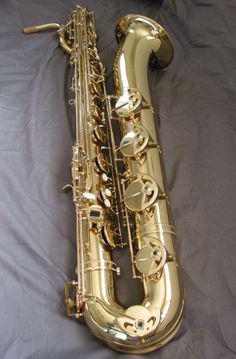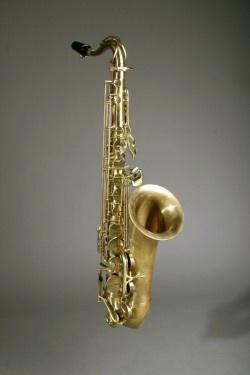The first image is the image on the left, the second image is the image on the right. Assess this claim about the two images: "At least one instrument is laying on a gray cloth.". Correct or not? Answer yes or no. Yes. The first image is the image on the left, the second image is the image on the right. Given the left and right images, does the statement "An image shows one saxophone that seems to be standing up on a flat ground, instead of lying flat or floating." hold true? Answer yes or no. No. 